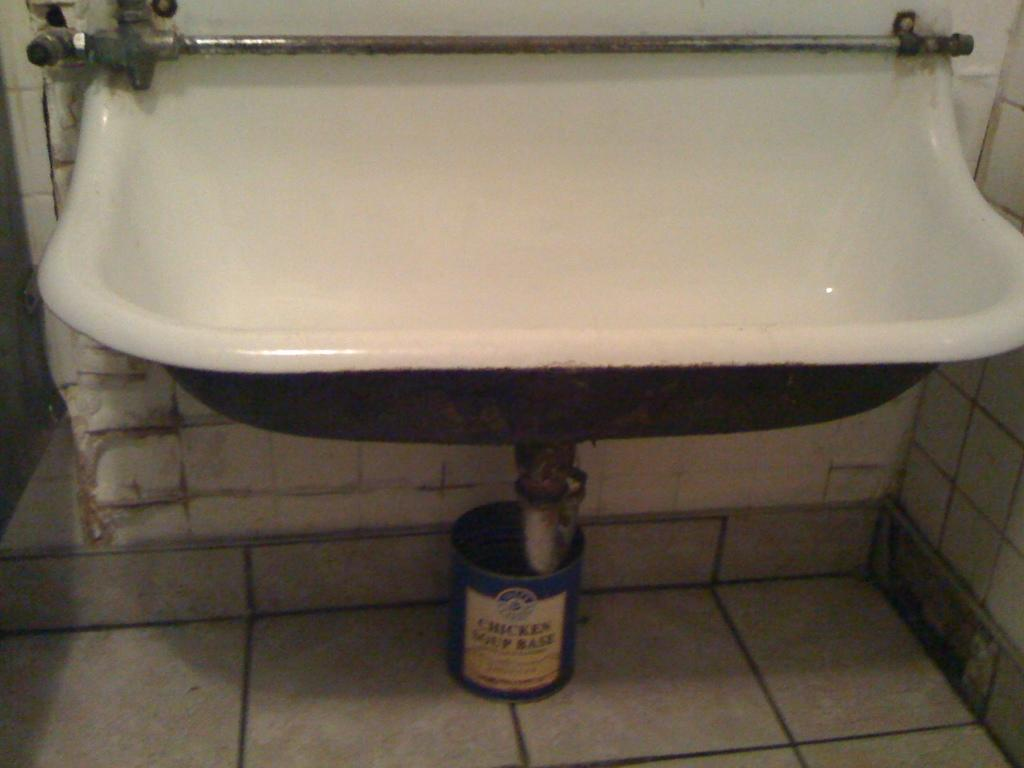What type of fixture is present in the image? There is a wash basin in the image. What color is the wash basin? The wash basin is white in color. What other object can be seen in the image? There is a bucket in the image. What color is the bucket? The bucket is blue in color. What type of breakfast is being served in the image? There is no breakfast present in the image; it only features a white wash basin and a blue bucket. Can you see any evidence of space travel in the image? There is no reference to space travel or any related objects in the image. 